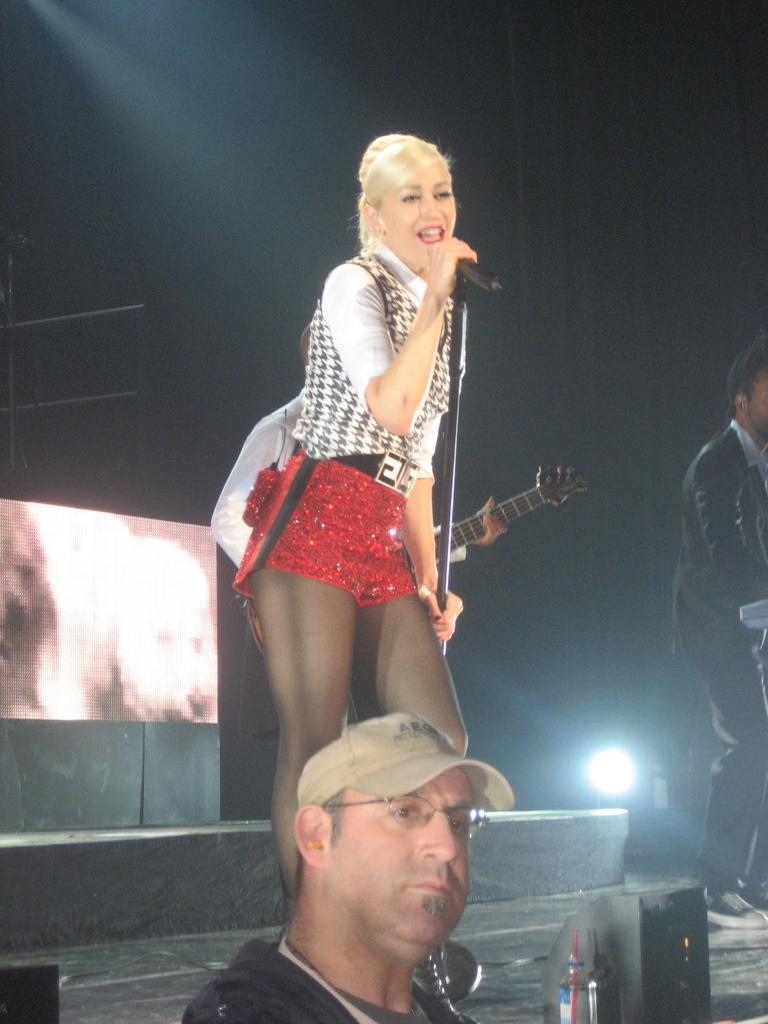How many people are standing in the image? There are three persons standing in the image. What are the people doing in the image? One person is holding a microphone and singing, while another person is holding a guitar. What can be seen in the background of the image? There is a focusing light and a screen in the background. What is the current temperature in the image? There is no information about the temperature in the image. Can you compare the size of the boys in the image? There are no boys present in the image. 